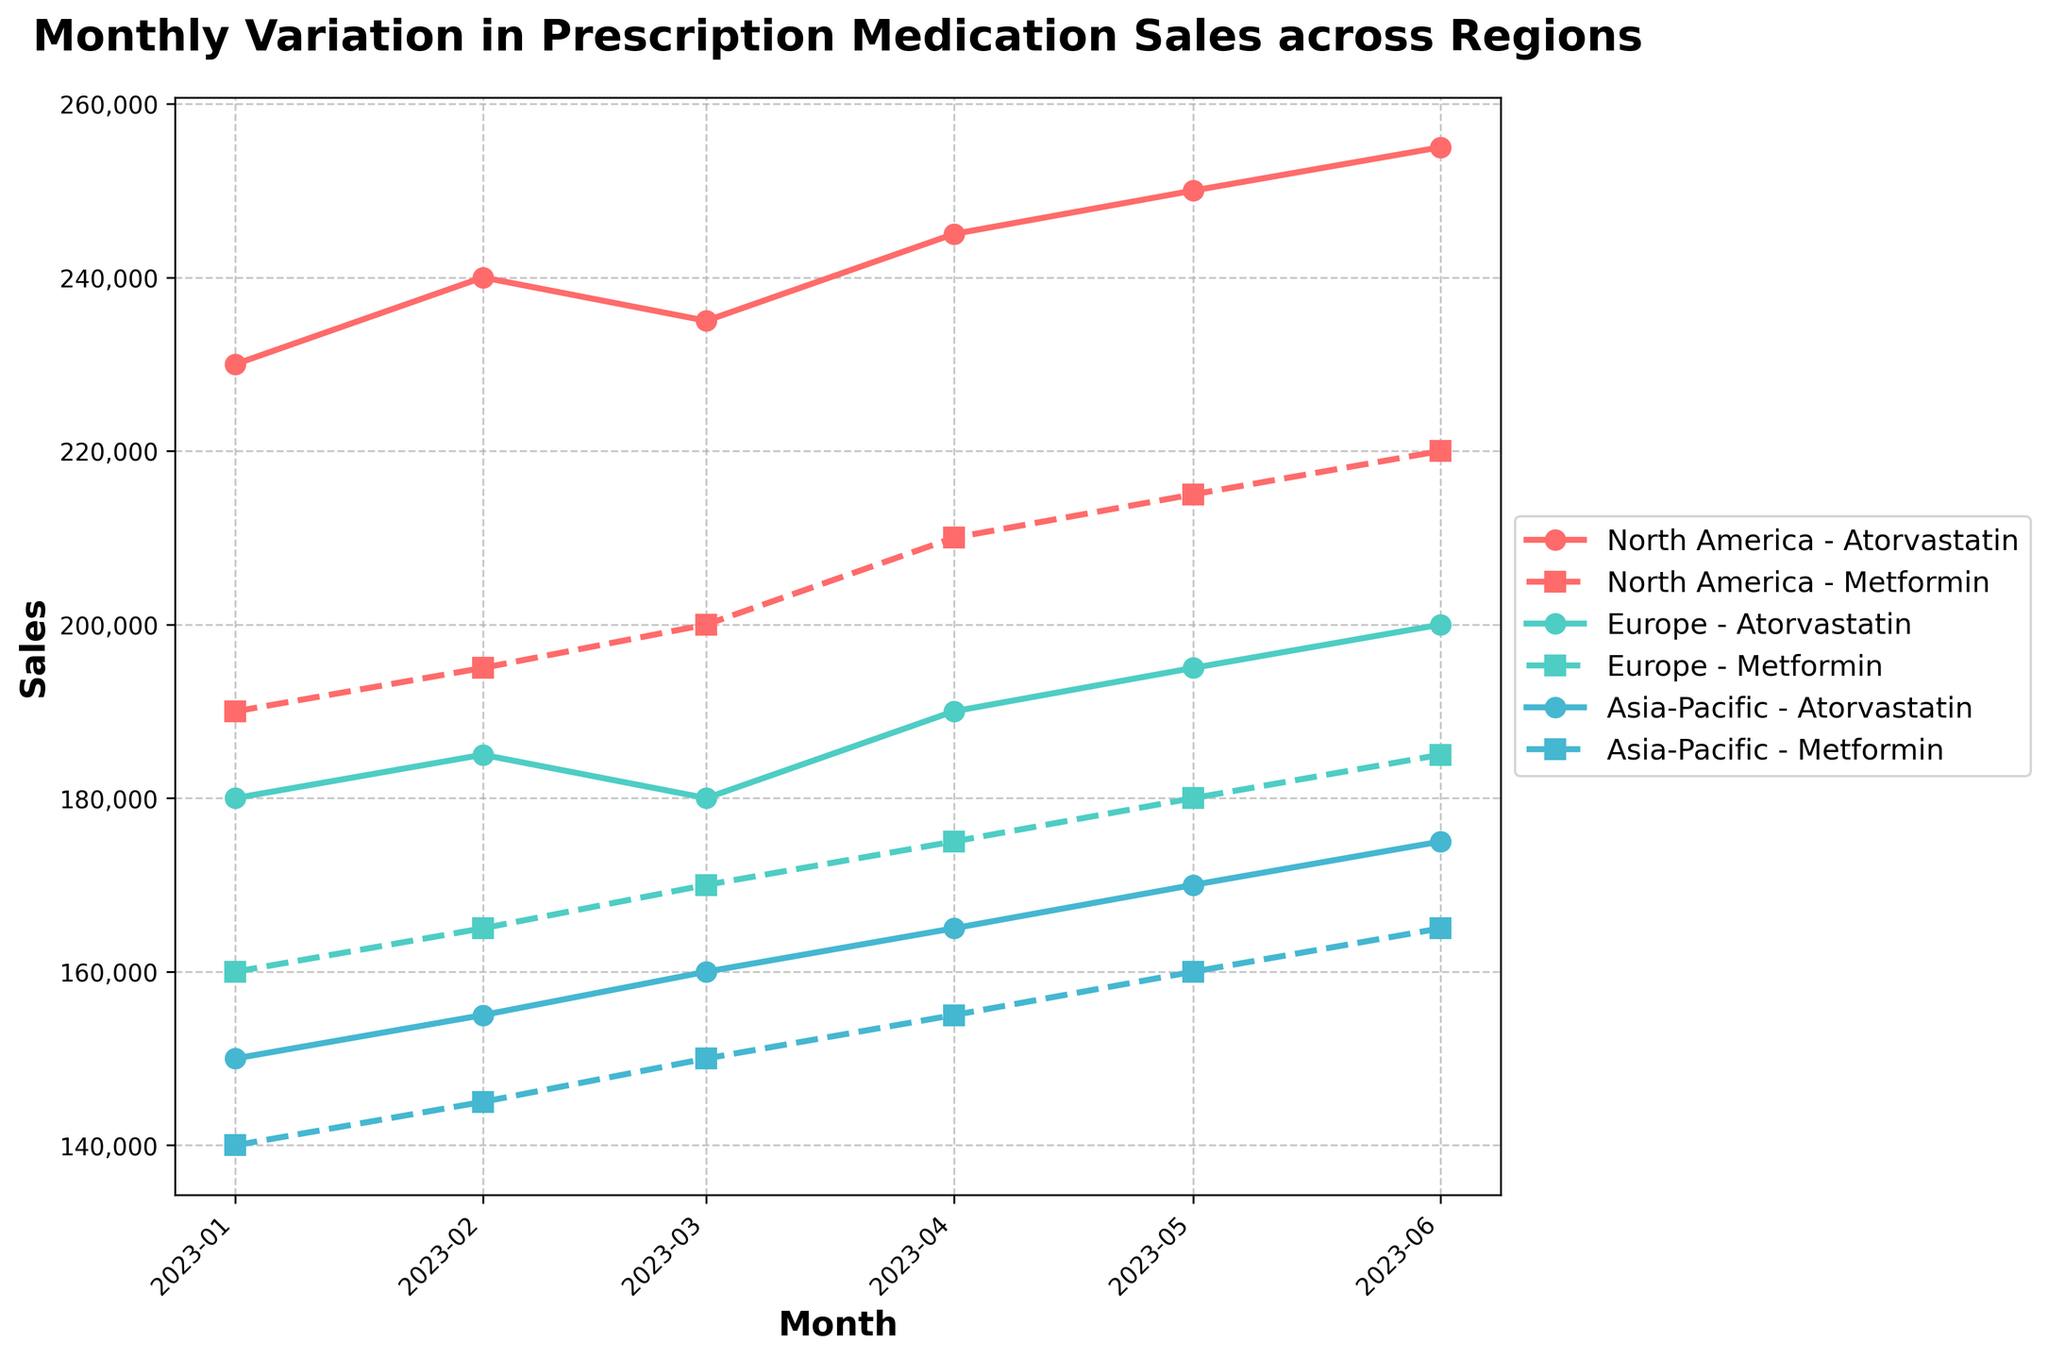What is the title of the plot? The plot title is located at the top of the figure and typically summarizes the main message of the plot. The title of this plot reads "Monthly Variation in Prescription Medication Sales across Regions".
Answer: Monthly Variation in Prescription Medication Sales across Regions How many regions are represented in the plot? Each line in the plot represents a different region. According to the legend, there are lines for North America, Europe, and Asia-Pacific. Count these entries to find the number of regions.
Answer: 3 Which medication had the highest sales in North America in June? Look for the peak point in June for North America. Then, compare the sales values of Atorvastatin and Metformin in that month. Atorvastatin has the highest sales in North America in June.
Answer: Atorvastatin What is the pattern of Metformin sales in Europe from January to June? Trace the line associated with Europe and Metformin from January to June. Note the increase or decrease at each month. The sales show a steady increase.
Answer: Steady increase Which region showed the highest increase in Atorvastatin sales from March to April? Find the Atorvastatin sales for each region in March and April. Subtract the March value from the April value for North America, Europe, and Asia-Pacific. The highest difference indicates the largest increase. North America had the highest increase.
Answer: North America What is the average sales of Atorvastatin in Asia-Pacific over the period shown? Note the sales values for Atorvastatin in Asia-Pacific each month (150,000; 155,000; 160,000; 165,000; 170,000; 175,000). Add these values and divide by the number of months. (150000 + 155000 + 160000 + 165000 + 170000 + 175000) / 6 = 162500.
Answer: 162500 In May, did Metformin sales in Europe exceed those in Asia-Pacific, and by how much if so? Compare the sales values of Metformin in Europe and Asia-Pacific in May. Subtract the smaller value from the larger value to get the difference. Metformin sales in Europe were 180,000 and in Asia-Pacific were 160,000. The difference is 20,000.
Answer: Yes, by 20000 Which month shows the highest variance in sales among the three regions for any medication? Look at each month and identify the range of sales values for a medication across the regions. Compare these to find the month with the largest range. June shows the highest variance in sales for both medications.
Answer: June 